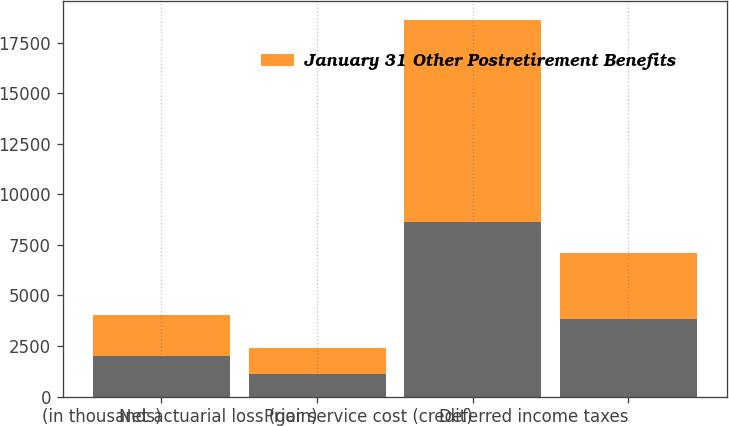Convert chart. <chart><loc_0><loc_0><loc_500><loc_500><stacked_bar_chart><ecel><fcel>(in thousands)<fcel>Net actuarial loss (gain)<fcel>Prior service cost (credit)<fcel>Deferred income taxes<nl><fcel>nan<fcel>2008<fcel>1112<fcel>8623<fcel>3854<nl><fcel>January 31 Other Postretirement Benefits<fcel>2008<fcel>1269<fcel>10004<fcel>3264<nl></chart> 